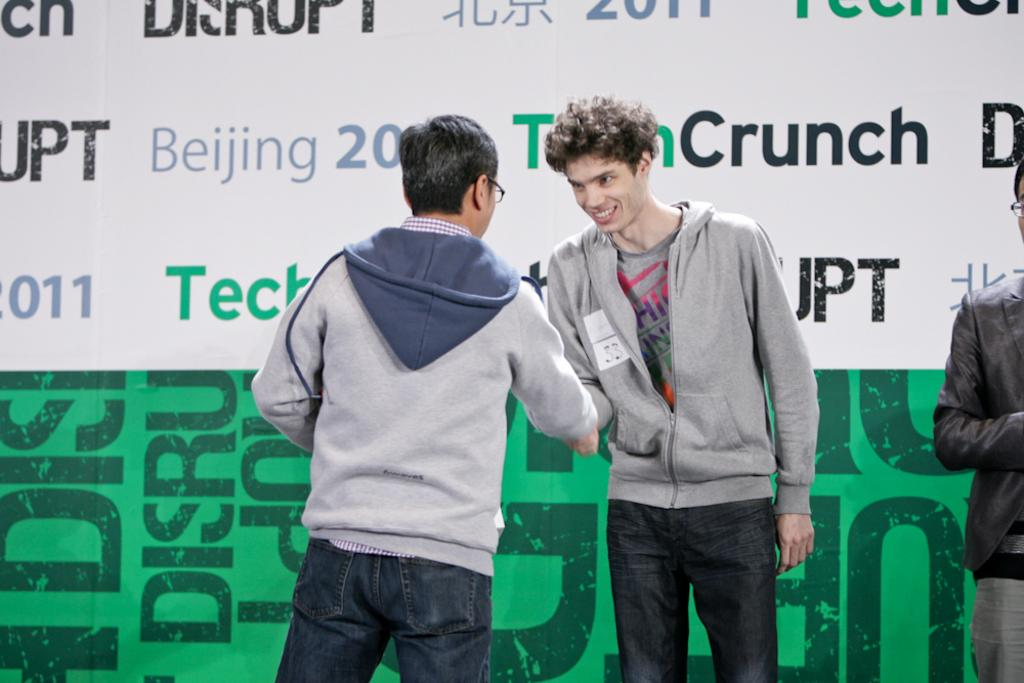What are the two men in the foreground of the image doing? The two men in the foreground of the image are standing and shaking hands. Can you describe the position of the third man in the image? The third man is standing on the right side of the image. What can be seen in the background of the image? There is a banner wall in the background of the image. What type of toothpaste is being advertised on the banner wall in the image? There is no toothpaste or advertisement visible on the banner wall in the image. What is the mass of the credit being exchanged between the two men in the image? There is no credit being exchanged between the two men in the image, and therefore no mass can be determined. 